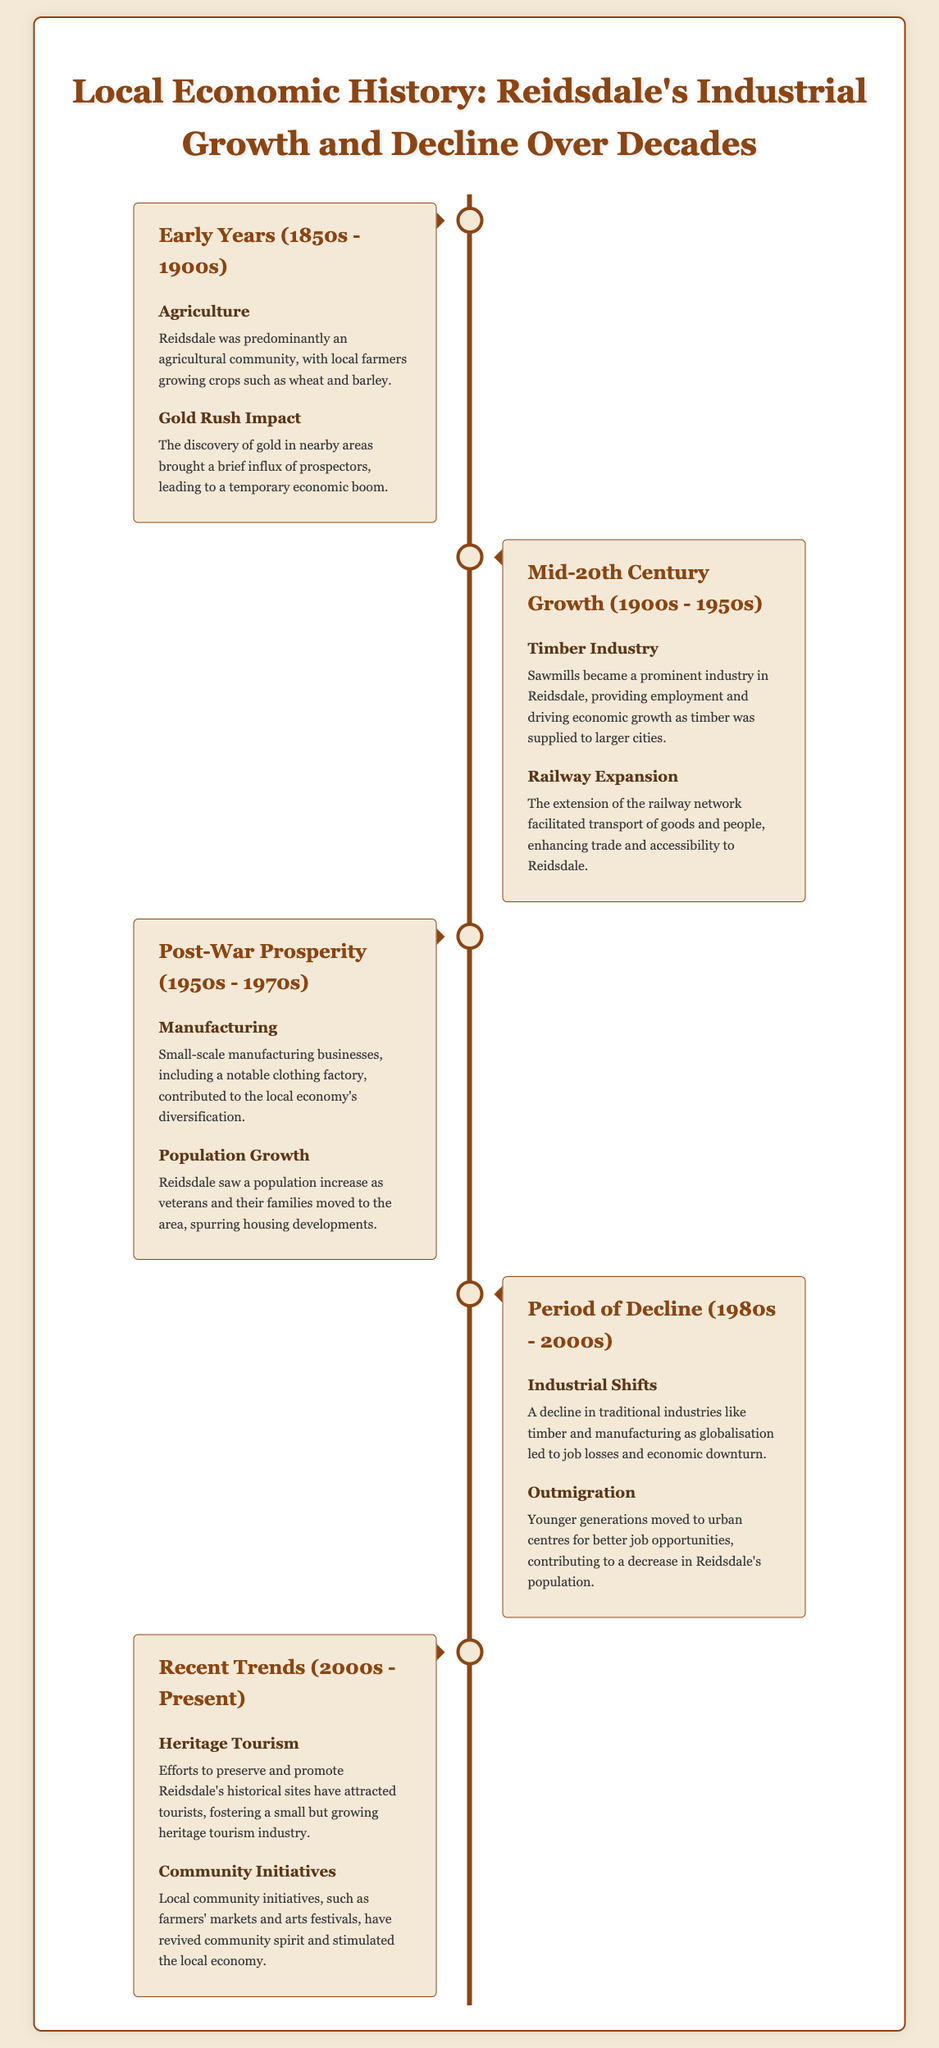What was the primary agricultural activity in Reidsdale during the early years? The document states that local farmers grew crops such as wheat and barley in Reidsdale during the early years.
Answer: Wheat and barley Which industry became prominent in Reidsdale between the 1900s and 1950s? The timeline mentions the timber industry as a major contributor to economic growth during this period.
Answer: Timber industry What contributed to the population increase in Reidsdale from the 1950s to the 1970s? The document notes that veterans and their families moving to the area spurred population growth.
Answer: Veterans and their families What significant economic change occurred in Reidsdale during the 1980s to 2000s? The document highlights a decline in traditional industries as a major economic shift during this period.
Answer: Industrial shifts What type of tourism has gained traction in Reidsdale in recent years? Efforts to preserve historical sites have led to the development of a heritage tourism industry, as mentioned in the document.
Answer: Heritage tourism What community initiatives have revived local spirit in Reidsdale? The document describes farmers' markets and arts festivals as community initiatives that have stimulated the local economy.
Answer: Farmers' markets and arts festivals What transport development enhanced trade in Reidsdale in the early 20th century? The extension of the railway network is indicated as a critical transport development that facilitated trade.
Answer: Railway expansion During which decades did Reidsdale experience post-war prosperity? The timeline states the period of post-war prosperity spanned from the 1950s to the 1970s.
Answer: 1950s - 1970s 